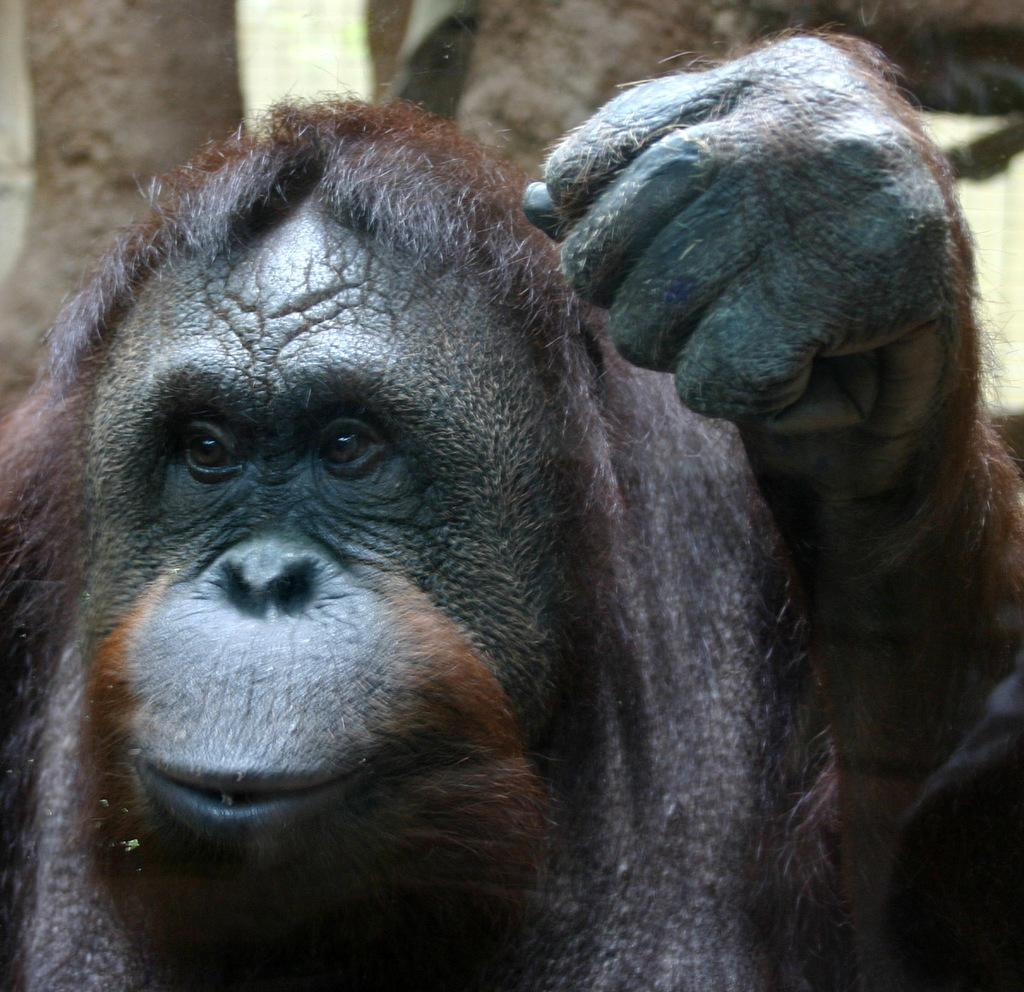What type of animal is in the image? There is an animal in the image, but the specific type cannot be determined from the provided facts. What color is the animal in the image? The animal is black in color. What can be seen behind the animal in the image? There are objects visible behind the animal, but their nature cannot be determined from the provided facts. Can you see any boats in the harbor in the image? There is no harbor or boats present in the image. What type of hill can be seen in the background of the image? There is no hill visible in the image. 